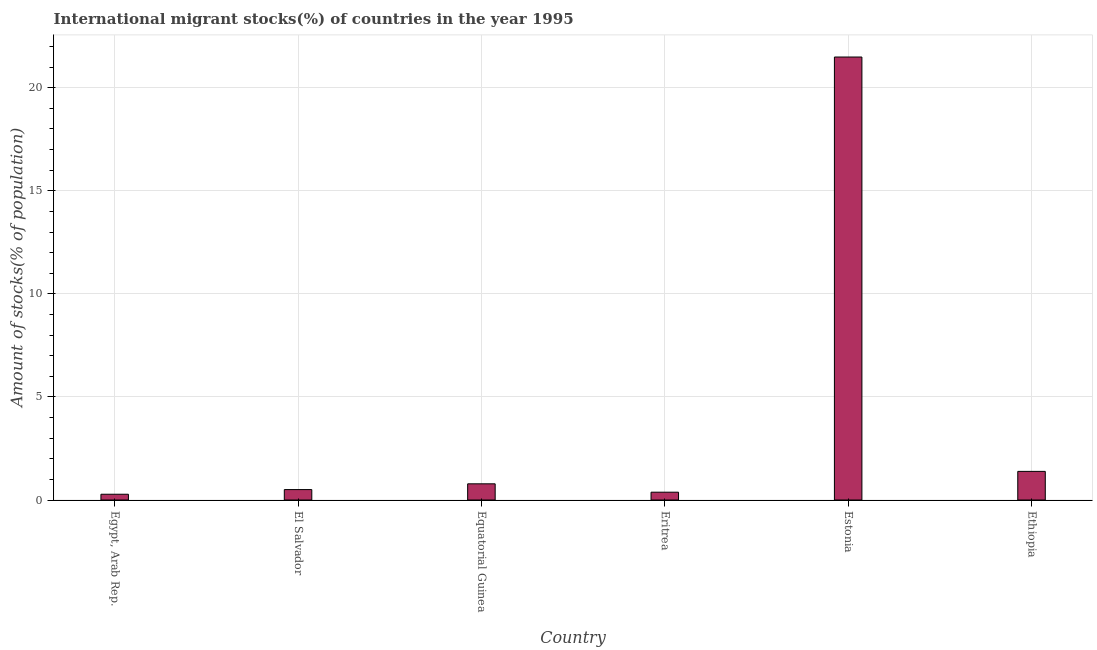Does the graph contain grids?
Provide a succinct answer. Yes. What is the title of the graph?
Your answer should be compact. International migrant stocks(%) of countries in the year 1995. What is the label or title of the X-axis?
Keep it short and to the point. Country. What is the label or title of the Y-axis?
Provide a short and direct response. Amount of stocks(% of population). What is the number of international migrant stocks in Egypt, Arab Rep.?
Your answer should be compact. 0.28. Across all countries, what is the maximum number of international migrant stocks?
Offer a very short reply. 21.49. Across all countries, what is the minimum number of international migrant stocks?
Give a very brief answer. 0.28. In which country was the number of international migrant stocks maximum?
Provide a short and direct response. Estonia. In which country was the number of international migrant stocks minimum?
Make the answer very short. Egypt, Arab Rep. What is the sum of the number of international migrant stocks?
Your answer should be compact. 24.83. What is the difference between the number of international migrant stocks in El Salvador and Ethiopia?
Your answer should be compact. -0.88. What is the average number of international migrant stocks per country?
Offer a terse response. 4.14. What is the median number of international migrant stocks?
Make the answer very short. 0.64. In how many countries, is the number of international migrant stocks greater than 11 %?
Give a very brief answer. 1. What is the ratio of the number of international migrant stocks in Egypt, Arab Rep. to that in Estonia?
Give a very brief answer. 0.01. What is the difference between the highest and the second highest number of international migrant stocks?
Provide a succinct answer. 20.1. Is the sum of the number of international migrant stocks in El Salvador and Estonia greater than the maximum number of international migrant stocks across all countries?
Give a very brief answer. Yes. What is the difference between the highest and the lowest number of international migrant stocks?
Give a very brief answer. 21.21. How many bars are there?
Your answer should be very brief. 6. How many countries are there in the graph?
Ensure brevity in your answer.  6. What is the difference between two consecutive major ticks on the Y-axis?
Give a very brief answer. 5. Are the values on the major ticks of Y-axis written in scientific E-notation?
Keep it short and to the point. No. What is the Amount of stocks(% of population) of Egypt, Arab Rep.?
Make the answer very short. 0.28. What is the Amount of stocks(% of population) of El Salvador?
Provide a succinct answer. 0.51. What is the Amount of stocks(% of population) of Equatorial Guinea?
Your answer should be very brief. 0.78. What is the Amount of stocks(% of population) in Eritrea?
Give a very brief answer. 0.38. What is the Amount of stocks(% of population) of Estonia?
Your response must be concise. 21.49. What is the Amount of stocks(% of population) of Ethiopia?
Provide a short and direct response. 1.39. What is the difference between the Amount of stocks(% of population) in Egypt, Arab Rep. and El Salvador?
Provide a succinct answer. -0.23. What is the difference between the Amount of stocks(% of population) in Egypt, Arab Rep. and Equatorial Guinea?
Your answer should be very brief. -0.51. What is the difference between the Amount of stocks(% of population) in Egypt, Arab Rep. and Eritrea?
Your response must be concise. -0.1. What is the difference between the Amount of stocks(% of population) in Egypt, Arab Rep. and Estonia?
Give a very brief answer. -21.21. What is the difference between the Amount of stocks(% of population) in Egypt, Arab Rep. and Ethiopia?
Make the answer very short. -1.11. What is the difference between the Amount of stocks(% of population) in El Salvador and Equatorial Guinea?
Ensure brevity in your answer.  -0.28. What is the difference between the Amount of stocks(% of population) in El Salvador and Eritrea?
Your response must be concise. 0.13. What is the difference between the Amount of stocks(% of population) in El Salvador and Estonia?
Make the answer very short. -20.98. What is the difference between the Amount of stocks(% of population) in El Salvador and Ethiopia?
Offer a terse response. -0.88. What is the difference between the Amount of stocks(% of population) in Equatorial Guinea and Eritrea?
Offer a terse response. 0.41. What is the difference between the Amount of stocks(% of population) in Equatorial Guinea and Estonia?
Ensure brevity in your answer.  -20.7. What is the difference between the Amount of stocks(% of population) in Equatorial Guinea and Ethiopia?
Your answer should be very brief. -0.6. What is the difference between the Amount of stocks(% of population) in Eritrea and Estonia?
Keep it short and to the point. -21.11. What is the difference between the Amount of stocks(% of population) in Eritrea and Ethiopia?
Provide a succinct answer. -1.01. What is the difference between the Amount of stocks(% of population) in Estonia and Ethiopia?
Ensure brevity in your answer.  20.1. What is the ratio of the Amount of stocks(% of population) in Egypt, Arab Rep. to that in El Salvador?
Offer a terse response. 0.55. What is the ratio of the Amount of stocks(% of population) in Egypt, Arab Rep. to that in Equatorial Guinea?
Provide a short and direct response. 0.36. What is the ratio of the Amount of stocks(% of population) in Egypt, Arab Rep. to that in Eritrea?
Keep it short and to the point. 0.74. What is the ratio of the Amount of stocks(% of population) in Egypt, Arab Rep. to that in Estonia?
Your answer should be very brief. 0.01. What is the ratio of the Amount of stocks(% of population) in Egypt, Arab Rep. to that in Ethiopia?
Ensure brevity in your answer.  0.2. What is the ratio of the Amount of stocks(% of population) in El Salvador to that in Equatorial Guinea?
Your response must be concise. 0.64. What is the ratio of the Amount of stocks(% of population) in El Salvador to that in Eritrea?
Make the answer very short. 1.33. What is the ratio of the Amount of stocks(% of population) in El Salvador to that in Estonia?
Make the answer very short. 0.02. What is the ratio of the Amount of stocks(% of population) in El Salvador to that in Ethiopia?
Give a very brief answer. 0.36. What is the ratio of the Amount of stocks(% of population) in Equatorial Guinea to that in Eritrea?
Your answer should be compact. 2.07. What is the ratio of the Amount of stocks(% of population) in Equatorial Guinea to that in Estonia?
Offer a very short reply. 0.04. What is the ratio of the Amount of stocks(% of population) in Equatorial Guinea to that in Ethiopia?
Make the answer very short. 0.56. What is the ratio of the Amount of stocks(% of population) in Eritrea to that in Estonia?
Your answer should be compact. 0.02. What is the ratio of the Amount of stocks(% of population) in Eritrea to that in Ethiopia?
Your response must be concise. 0.27. What is the ratio of the Amount of stocks(% of population) in Estonia to that in Ethiopia?
Offer a very short reply. 15.48. 